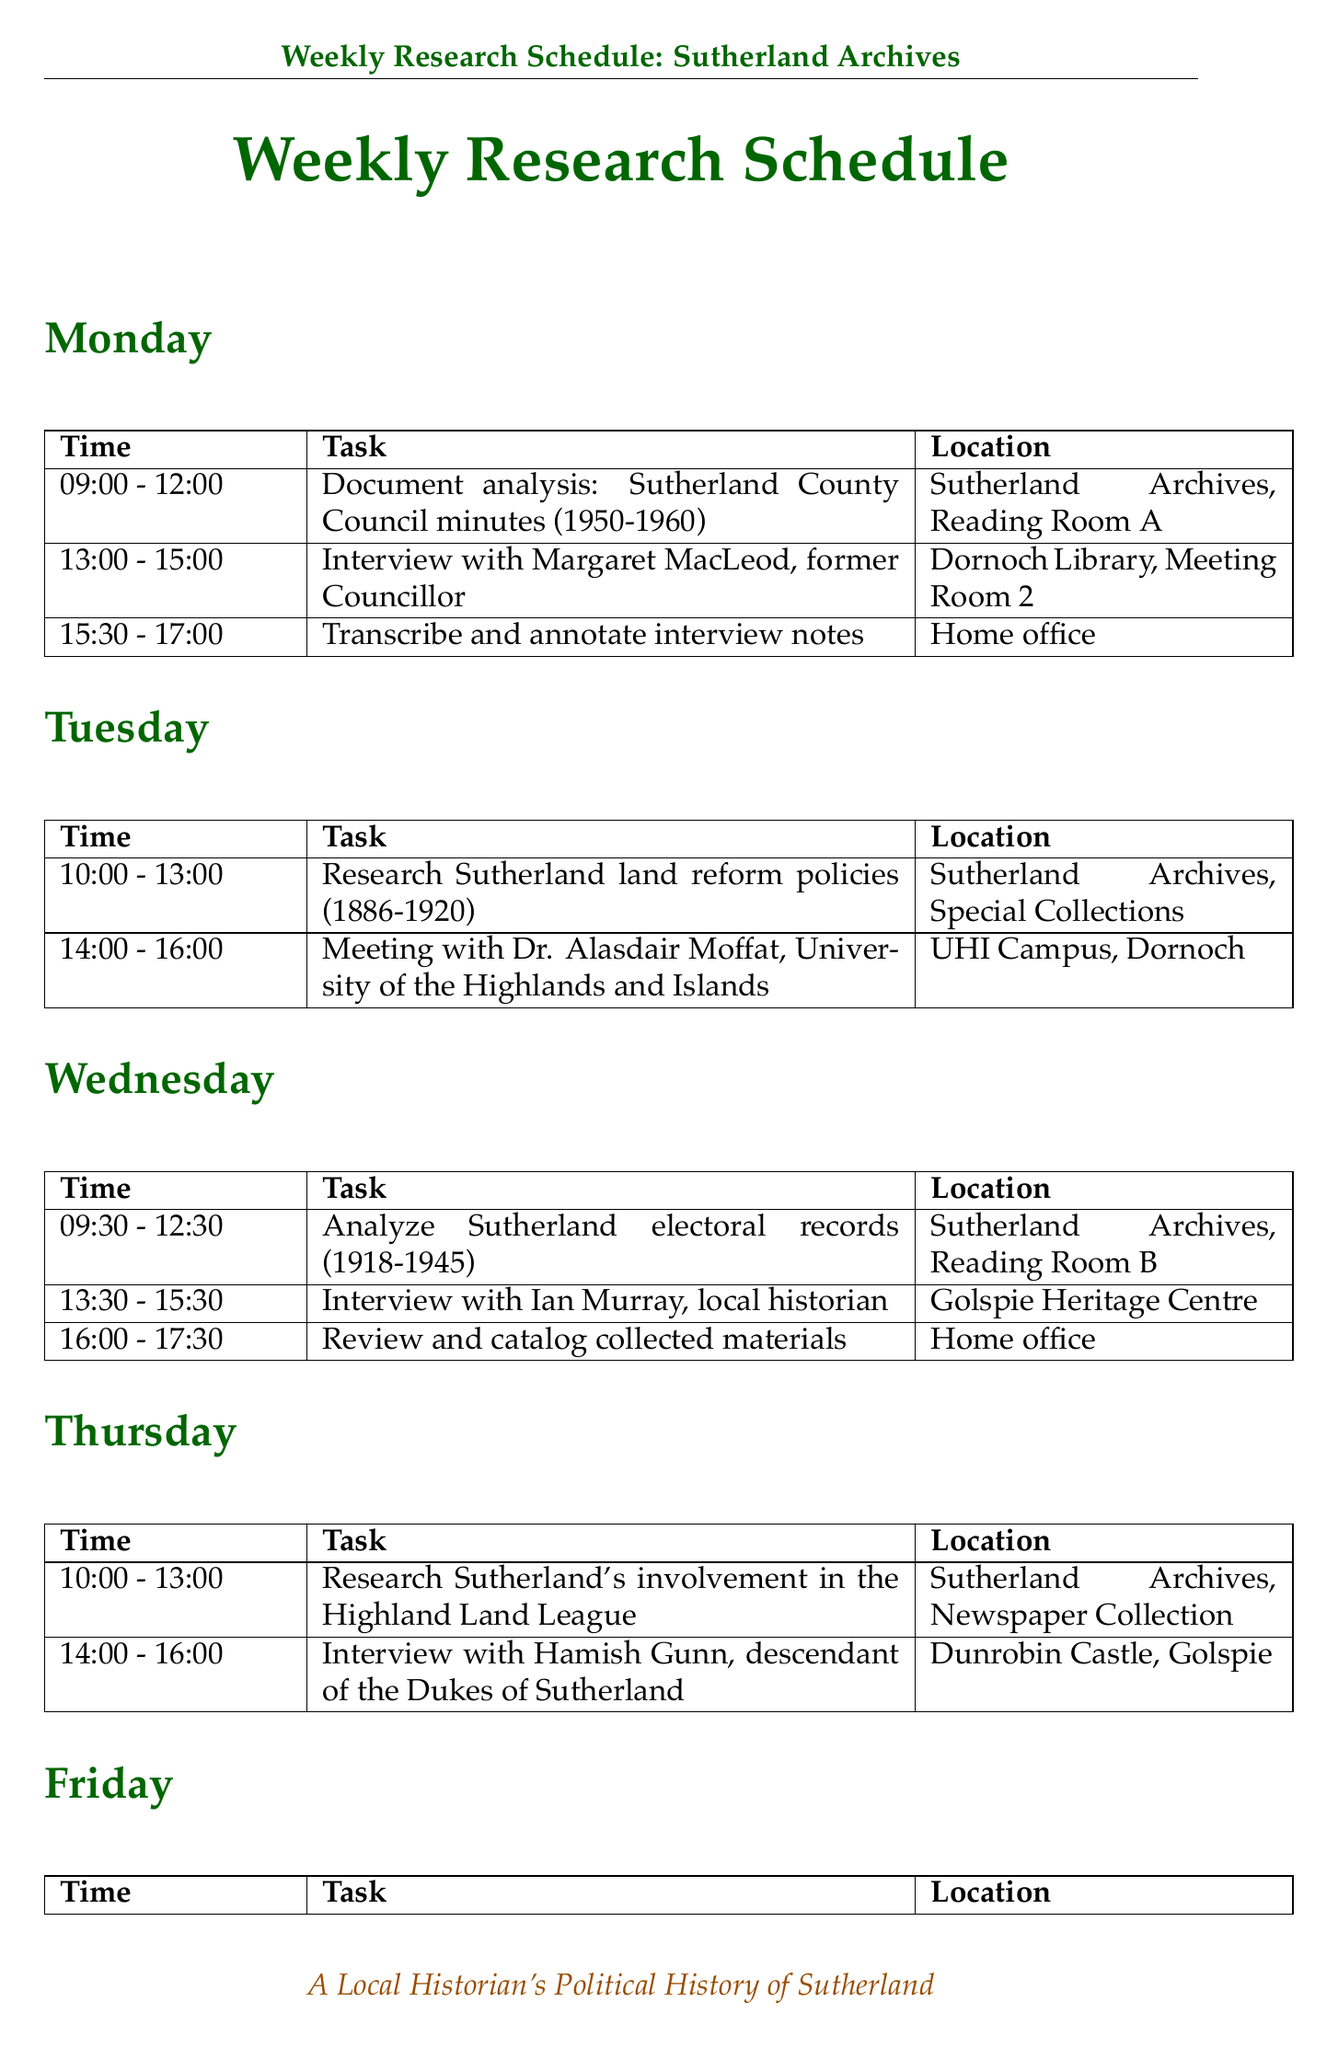What is scheduled for Monday at 9:00 AM? The task scheduled is "Document analysis: Sutherland County Council minutes (1950-1960)."
Answer: Document analysis: Sutherland County Council minutes (1950-1960) Who is interviewed on Tuesday? The notable figure interviewed on Tuesday is Dr. Alasdair Moffat.
Answer: Dr. Alasdair Moffat What is the location for the interview with Hamish Gunn? The document specifies that the interview with Hamish Gunn will be at Dunrobin Castle, Golspie.
Answer: Dunrobin Castle, Golspie How long is the document analysis session on Wednesday? The document analysis on Wednesday lasts from 9:30 AM to 12:30 PM, which is 3 hours.
Answer: 3 hours What is the main research topic addressed on Thursday? The main research topic on Thursday is Sutherland's involvement in the Highland Land League.
Answer: Sutherland's involvement in the Highland Land League What time is the meeting with Fiona MacDonald? The meeting with Fiona MacDonald is scheduled for 1:00 PM to 3:00 PM on Friday.
Answer: 1:00 PM to 3:00 PM How many activities are listed on Friday? There are three activities scheduled for Friday within the document.
Answer: Three activities What location is common for document analysis tasks? The common location for document analysis tasks is Sutherland Archives.
Answer: Sutherland Archives 